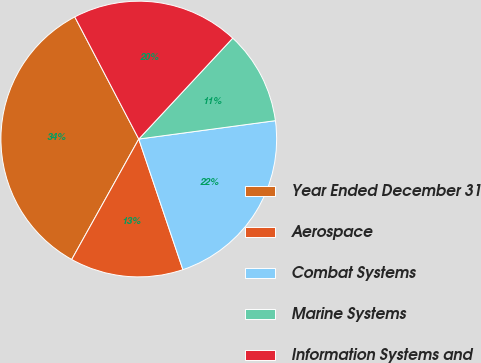Convert chart to OTSL. <chart><loc_0><loc_0><loc_500><loc_500><pie_chart><fcel>Year Ended December 31<fcel>Aerospace<fcel>Combat Systems<fcel>Marine Systems<fcel>Information Systems and<nl><fcel>34.23%<fcel>13.27%<fcel>21.94%<fcel>10.94%<fcel>19.61%<nl></chart> 